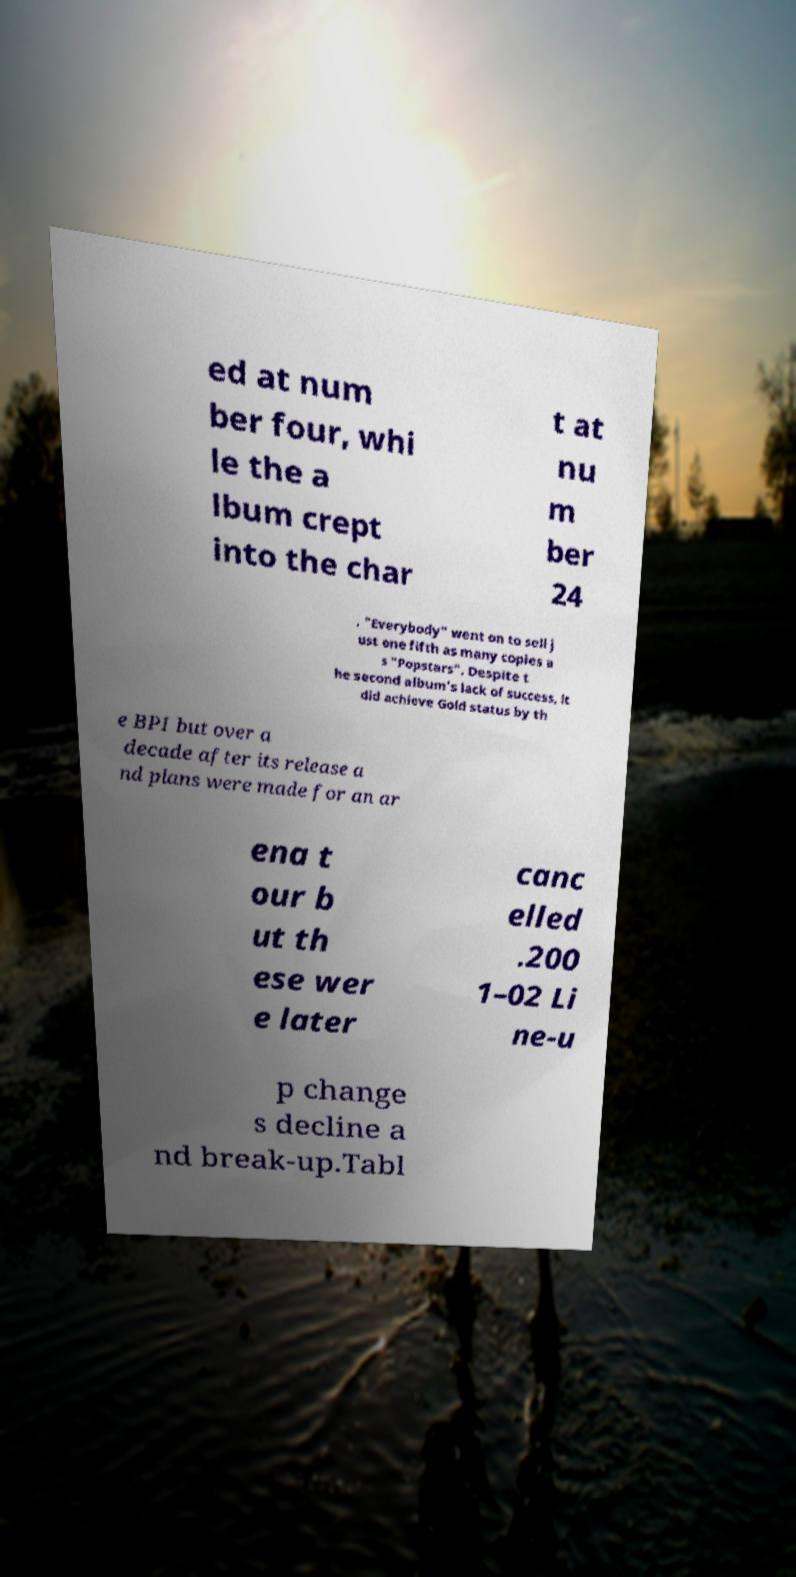What messages or text are displayed in this image? I need them in a readable, typed format. ed at num ber four, whi le the a lbum crept into the char t at nu m ber 24 . "Everybody" went on to sell j ust one fifth as many copies a s "Popstars". Despite t he second album's lack of success, it did achieve Gold status by th e BPI but over a decade after its release a nd plans were made for an ar ena t our b ut th ese wer e later canc elled .200 1–02 Li ne-u p change s decline a nd break-up.Tabl 